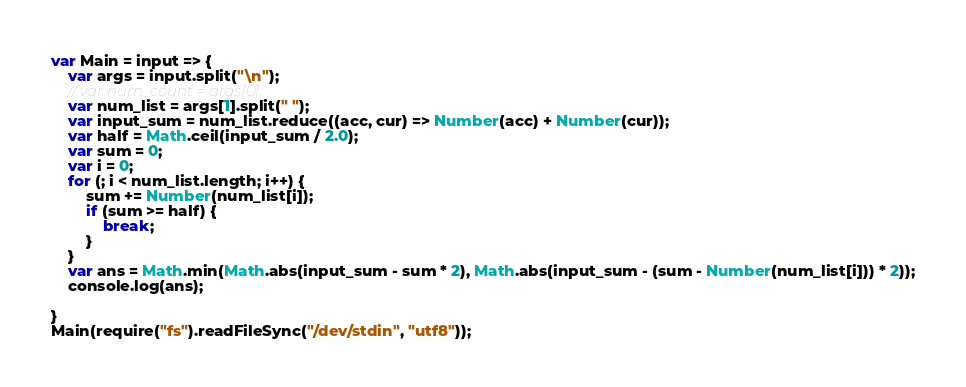<code> <loc_0><loc_0><loc_500><loc_500><_JavaScript_>var Main = input => {
    var args = input.split("\n");
    // var num_count = args[0];
    var num_list = args[1].split(" ");
    var input_sum = num_list.reduce((acc, cur) => Number(acc) + Number(cur));
    var half = Math.ceil(input_sum / 2.0);
    var sum = 0;
    var i = 0;
    for (; i < num_list.length; i++) {
        sum += Number(num_list[i]);
        if (sum >= half) {
            break;
        }
    }
    var ans = Math.min(Math.abs(input_sum - sum * 2), Math.abs(input_sum - (sum - Number(num_list[i])) * 2));
    console.log(ans);

}
Main(require("fs").readFileSync("/dev/stdin", "utf8"));</code> 